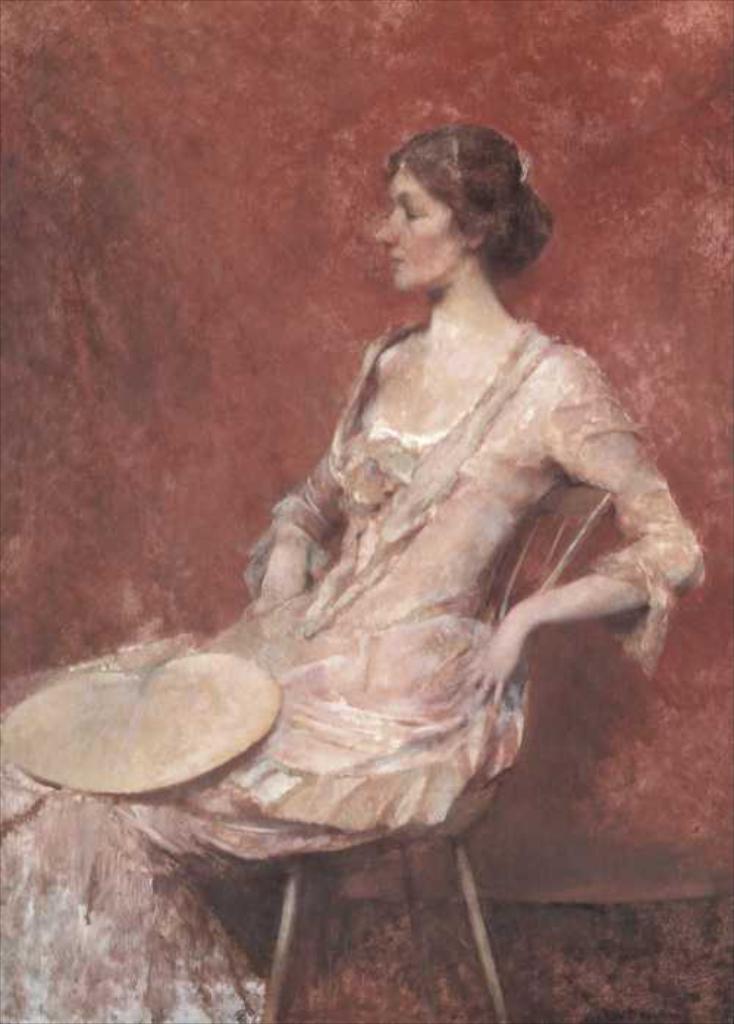How would you summarize this image in a sentence or two? In this image I can see the painting in which I can see a woman is sitting and the red colored background. 